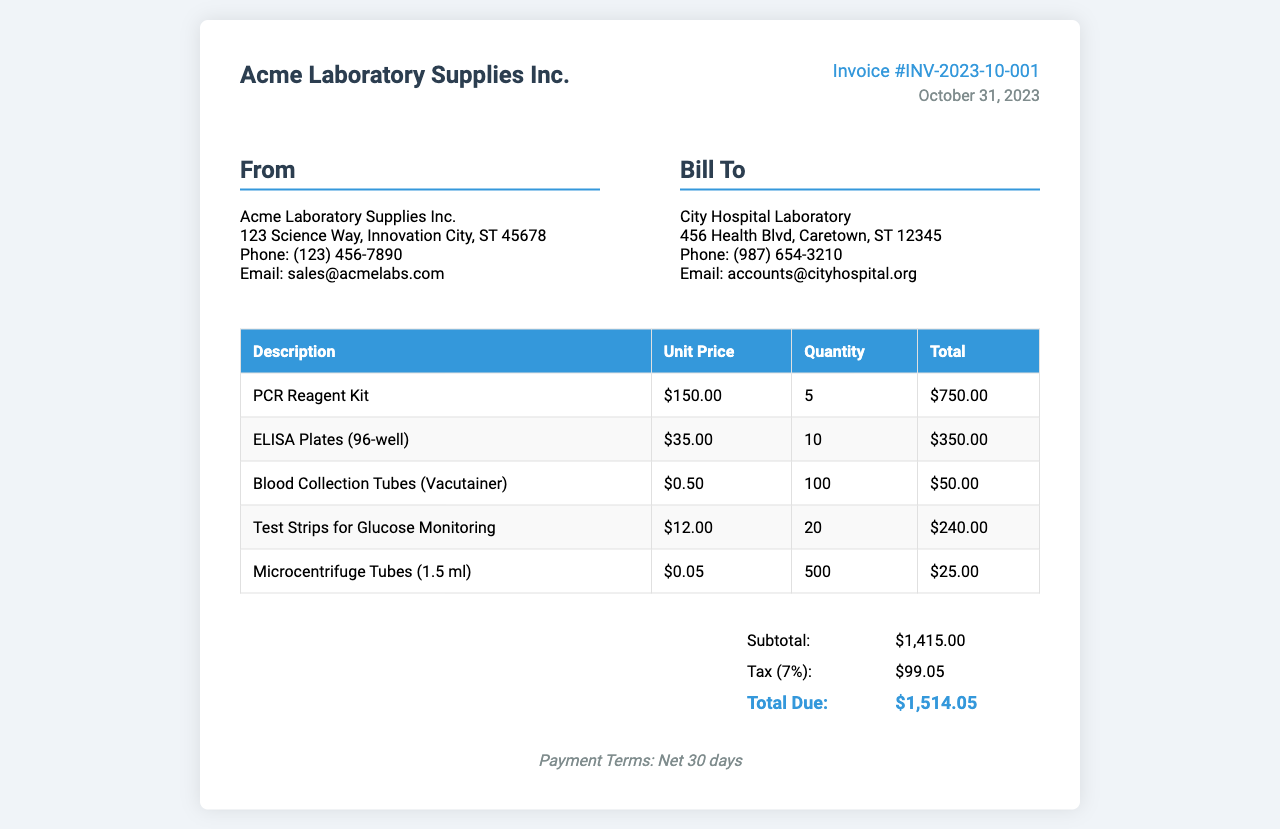What is the invoice number? The invoice number can be found in the invoice details section at the top.
Answer: INV-2023-10-001 What is the date of the invoice? The date is listed in the invoice details section beneath the invoice number.
Answer: October 31, 2023 What is the total due amount? The total due amount is found in the summary table at the bottom of the invoice.
Answer: $1,514.05 How many PCR Reagent Kits were purchased? The quantity of PCR Reagent Kits is detailed in the items table.
Answer: 5 What is the unit price of ELISA Plates (96-well)? The unit price is listed in the items table next to the corresponding item.
Answer: $35.00 What is the subtotal amount before tax? The subtotal is provided in the summary table above the tax amount.
Answer: $1,415.00 What is the tax rate applied to the invoice? The tax rate can be inferred from the tax amount calculation in the summary table.
Answer: 7% What is the total quantity of Blood Collection Tubes purchased? The total quantity is indicated in the items table alongside the item's description.
Answer: 100 What payment terms are specified in the invoice? The payment terms are noted at the bottom of the invoice.
Answer: Net 30 days 